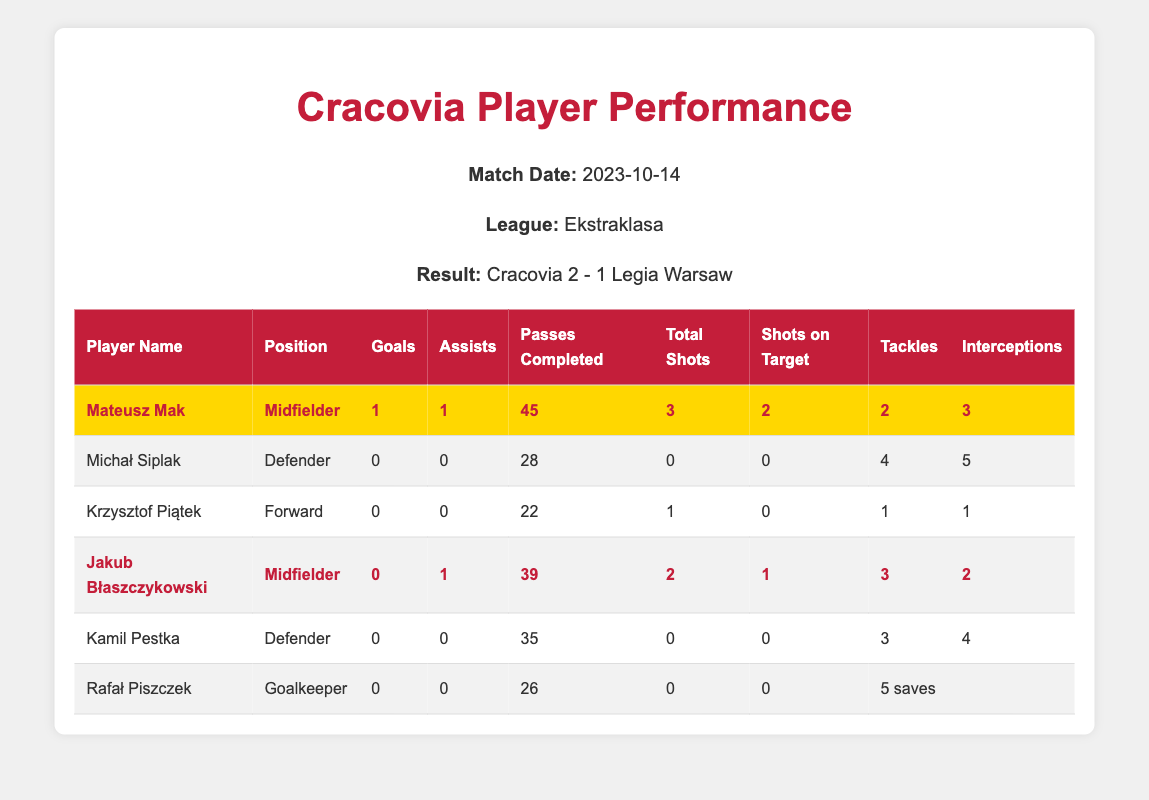What is the total number of goals scored by Cracovia players in this match? The table shows that Mateusz Mak scored 1 goal and the other players scored 0 goals. So, the total goals scored are 1 + 0 + 0 + 0 + 0 = 1.
Answer: 1 Who had the highest number of assists in the match? From the table, Mateusz Mak has 1 assist and Jakub Błaszczykowski has 1 assist too. No other player has any assists. So, the maximum is 1 assist, shared between two players.
Answer: 1 Did any player achieve a clean sheet in this match? Looking at the goalkeeper's performance, Rafał Piszczek has 0 goals conceded along with 5 saves. However, since the team conceded 1 goal, he did not achieve a clean sheet.
Answer: No How many total passes were completed by all players combined? Adding the completed passes: 45 (Mateusz Mak) + 28 (Michał Siplak) + 22 (Krzysztof Piątek) + 39 (Jakub Błaszczykowski) + 35 (Kamil Pestka) + 26 (Rafał Piszczek) = 195 completed passes in total.
Answer: 195 Which player was awarded Man of the Match? The table indicates that Mateusz Mak has the "manOfTheMatch" attribute marked as true. Therefore, he was awarded Man of the Match.
Answer: Mateusz Mak How many total shots did the team's forwards take? In the table, Krzysztof Piątek, the only forward listed, took 1 total shot. Thus, his total shots are counted.
Answer: 1 Is it true that Jakub Błaszczykowski had more shots on target than Mateusz Mak? Jakub Błaszczykowski had 1 shot on target, while Mateusz Mak had 2 shots on target. Therefore, the statement is false.
Answer: No What is the average number of tackles made by defenders in this match? Defenders in the match are Michał Siplak and Kamil Pestka, with tackles of 4 and 3 respectively. The average tackles are (4 + 3) / 2 = 3.5.
Answer: 3.5 Which player made the most interceptions? The most interceptions were made by Michał Siplak with 5 interceptions. Therefore, he is the player who made the most interceptions.
Answer: Michał Siplak What percentage of total shots did Mateusz Mak convert into goals? Mateusz Mak had 3 total shots, with 1 resulting in a goal. The conversion percentage is (1/3)*100 = 33.33%.
Answer: 33.33% 